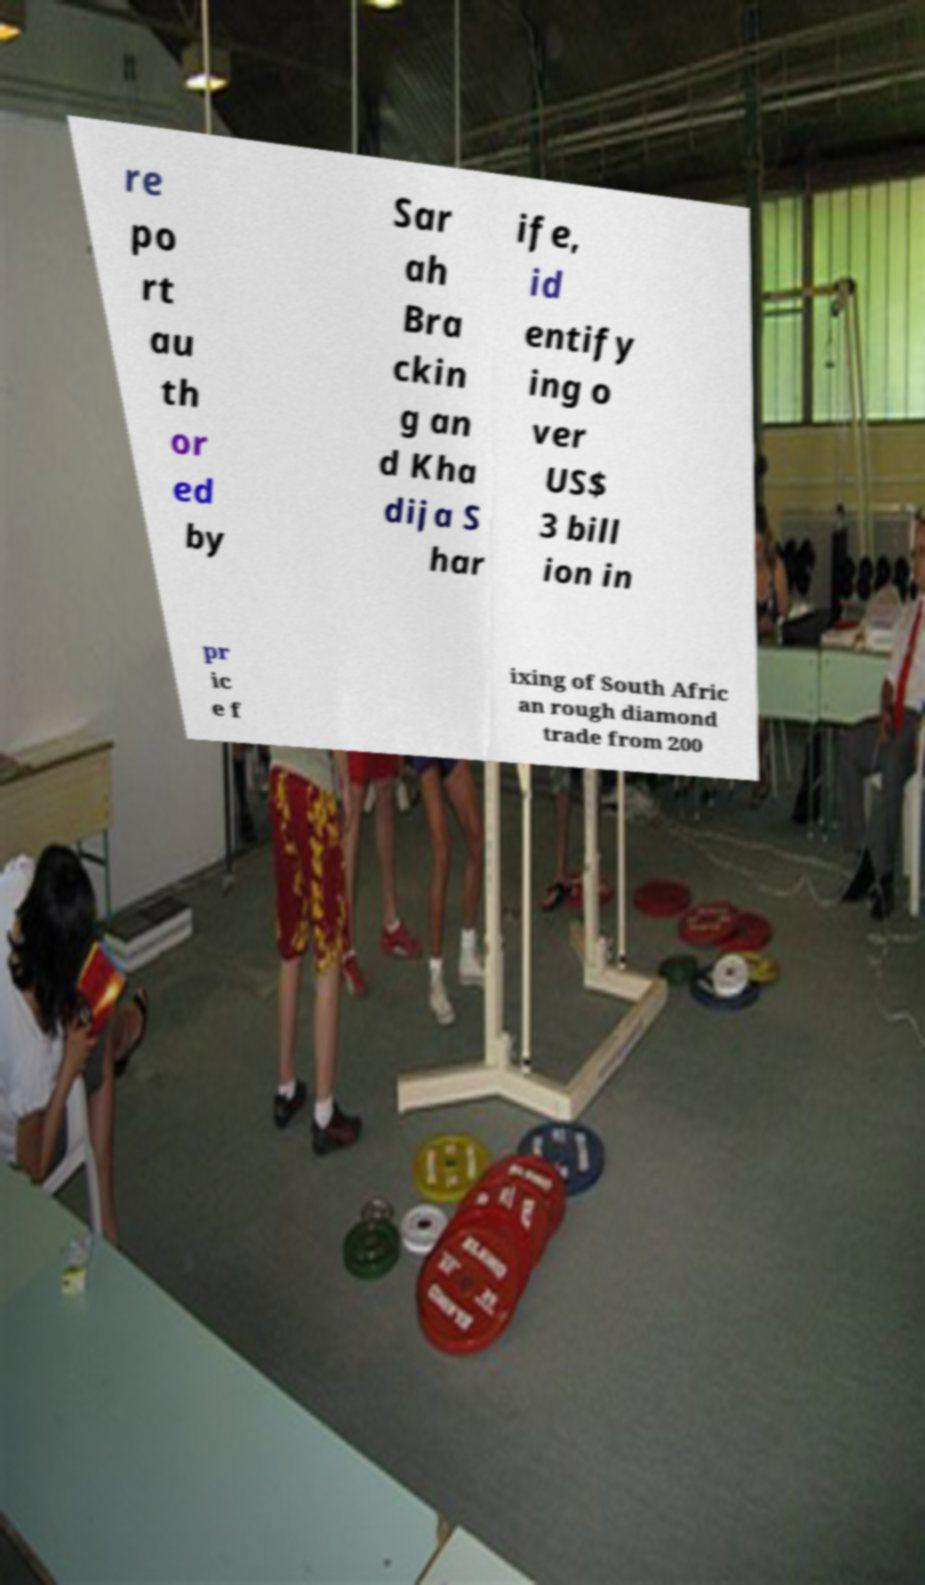Please read and relay the text visible in this image. What does it say? re po rt au th or ed by Sar ah Bra ckin g an d Kha dija S har ife, id entify ing o ver US$ 3 bill ion in pr ic e f ixing of South Afric an rough diamond trade from 200 